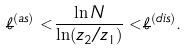Convert formula to latex. <formula><loc_0><loc_0><loc_500><loc_500>\overline { \ell } ^ { ( a s ) } < \frac { \ln N } { \ln ( z _ { 2 } / z _ { 1 } ) } < \overline { \ell } ^ { ( d i s ) } .</formula> 